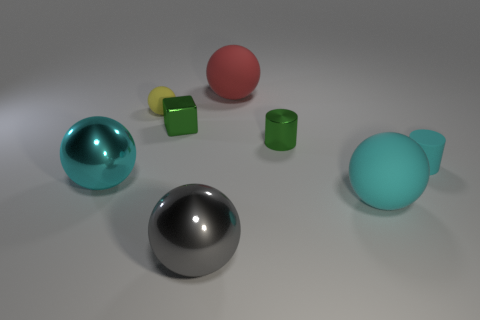How many things are big gray rubber spheres or things?
Provide a short and direct response. 8. There is a gray shiny object to the left of the large red ball; what shape is it?
Offer a terse response. Sphere. What color is the small ball that is the same material as the small cyan thing?
Provide a short and direct response. Yellow. What material is the gray object that is the same shape as the tiny yellow matte object?
Make the answer very short. Metal. The small cyan rubber object has what shape?
Your response must be concise. Cylinder. There is a tiny object that is both on the right side of the small yellow rubber object and to the left of the tiny green cylinder; what material is it?
Ensure brevity in your answer.  Metal. The green object that is the same material as the green cylinder is what shape?
Offer a very short reply. Cube. What is the size of the gray thing that is made of the same material as the small block?
Keep it short and to the point. Large. What shape is the big thing that is both in front of the large cyan shiny sphere and left of the big red object?
Ensure brevity in your answer.  Sphere. How big is the shiny thing that is in front of the shiny object that is on the left side of the yellow rubber thing?
Offer a very short reply. Large. 